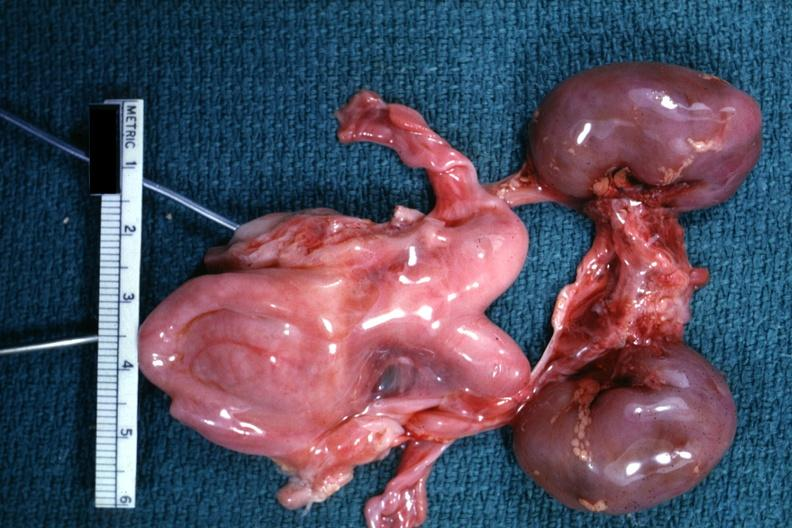s uterus present?
Answer the question using a single word or phrase. Yes 